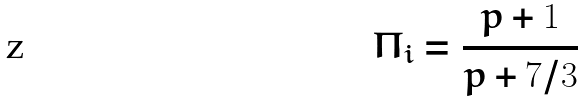Convert formula to latex. <formula><loc_0><loc_0><loc_500><loc_500>\Pi _ { i } = \frac { p + 1 } { p + 7 / 3 }</formula> 